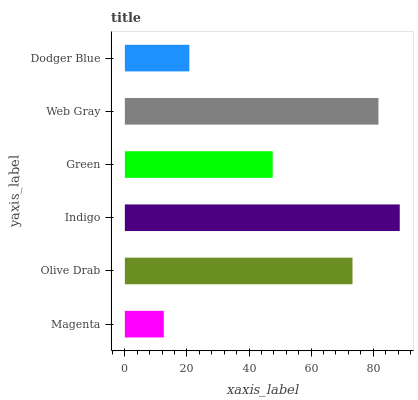Is Magenta the minimum?
Answer yes or no. Yes. Is Indigo the maximum?
Answer yes or no. Yes. Is Olive Drab the minimum?
Answer yes or no. No. Is Olive Drab the maximum?
Answer yes or no. No. Is Olive Drab greater than Magenta?
Answer yes or no. Yes. Is Magenta less than Olive Drab?
Answer yes or no. Yes. Is Magenta greater than Olive Drab?
Answer yes or no. No. Is Olive Drab less than Magenta?
Answer yes or no. No. Is Olive Drab the high median?
Answer yes or no. Yes. Is Green the low median?
Answer yes or no. Yes. Is Web Gray the high median?
Answer yes or no. No. Is Magenta the low median?
Answer yes or no. No. 